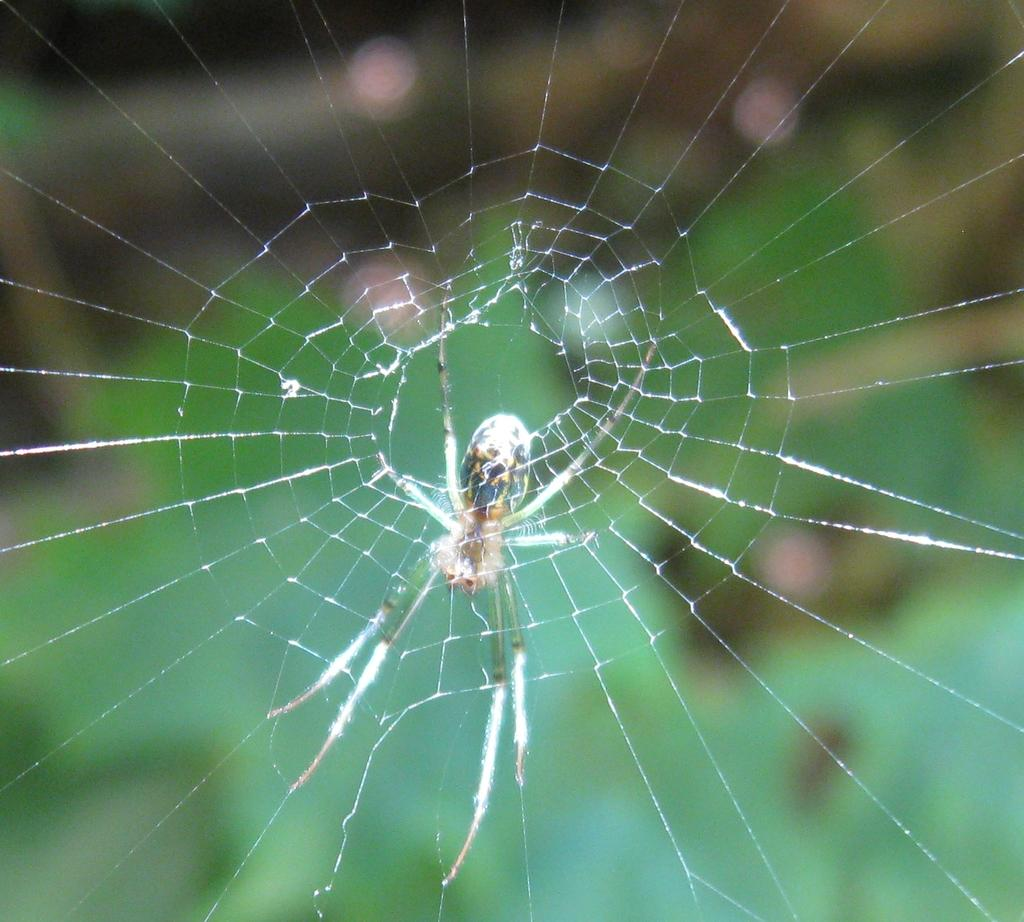What is the main subject of the image? There is a spider in the image. What is associated with the spider in the image? There is a spider web in the image. Can you describe the background of the image? The background of the image is blurred. What type of trousers is the spider wearing in the image? Spiders do not wear trousers, so this question cannot be answered. How is the distribution of spiders in the image? There is only one spider visible in the image, so it cannot be described as a distribution. 